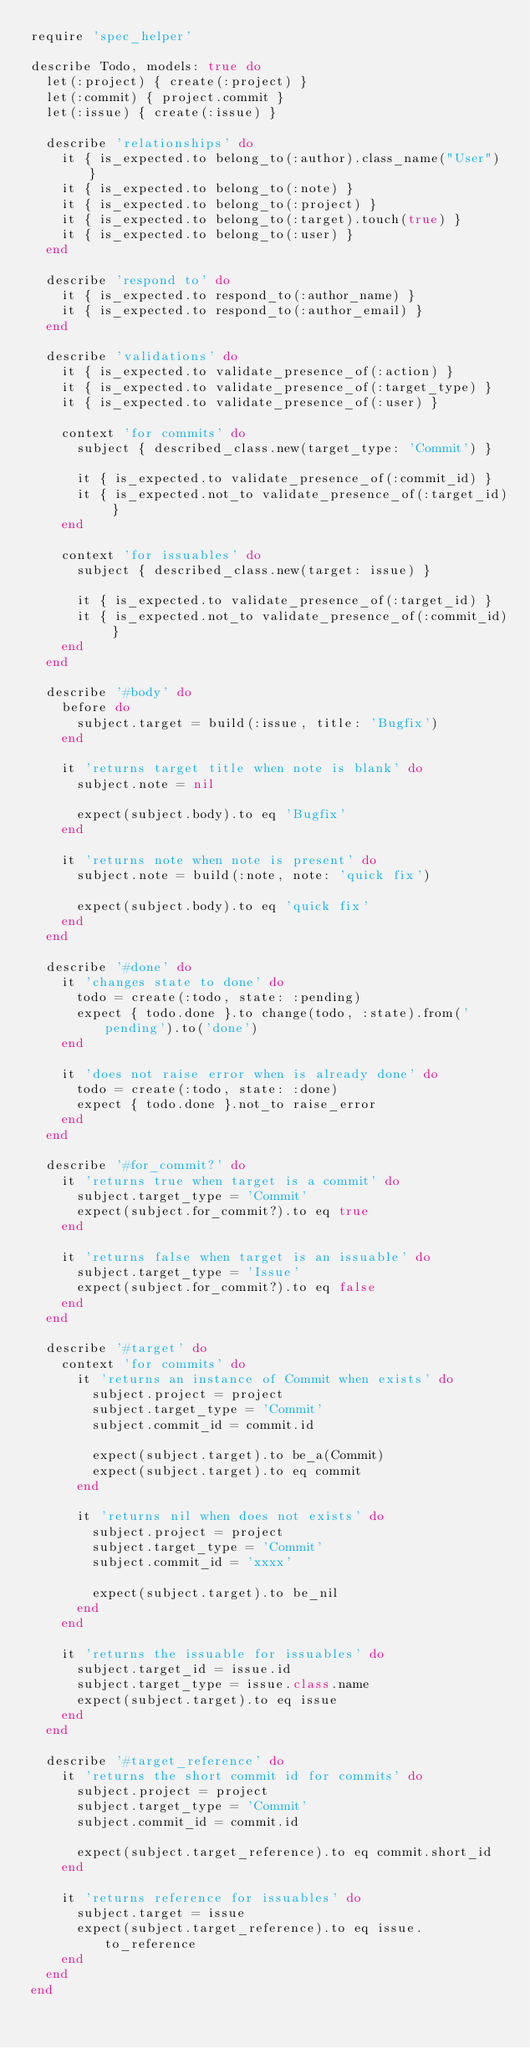Convert code to text. <code><loc_0><loc_0><loc_500><loc_500><_Ruby_>require 'spec_helper'

describe Todo, models: true do
  let(:project) { create(:project) }
  let(:commit) { project.commit }
  let(:issue) { create(:issue) }

  describe 'relationships' do
    it { is_expected.to belong_to(:author).class_name("User") }
    it { is_expected.to belong_to(:note) }
    it { is_expected.to belong_to(:project) }
    it { is_expected.to belong_to(:target).touch(true) }
    it { is_expected.to belong_to(:user) }
  end

  describe 'respond to' do
    it { is_expected.to respond_to(:author_name) }
    it { is_expected.to respond_to(:author_email) }
  end

  describe 'validations' do
    it { is_expected.to validate_presence_of(:action) }
    it { is_expected.to validate_presence_of(:target_type) }
    it { is_expected.to validate_presence_of(:user) }

    context 'for commits' do
      subject { described_class.new(target_type: 'Commit') }

      it { is_expected.to validate_presence_of(:commit_id) }
      it { is_expected.not_to validate_presence_of(:target_id) }
    end

    context 'for issuables' do
      subject { described_class.new(target: issue) }

      it { is_expected.to validate_presence_of(:target_id) }
      it { is_expected.not_to validate_presence_of(:commit_id) }
    end
  end

  describe '#body' do
    before do
      subject.target = build(:issue, title: 'Bugfix')
    end

    it 'returns target title when note is blank' do
      subject.note = nil

      expect(subject.body).to eq 'Bugfix'
    end

    it 'returns note when note is present' do
      subject.note = build(:note, note: 'quick fix')

      expect(subject.body).to eq 'quick fix'
    end
  end

  describe '#done' do
    it 'changes state to done' do
      todo = create(:todo, state: :pending)
      expect { todo.done }.to change(todo, :state).from('pending').to('done')
    end

    it 'does not raise error when is already done' do
      todo = create(:todo, state: :done)
      expect { todo.done }.not_to raise_error
    end
  end

  describe '#for_commit?' do
    it 'returns true when target is a commit' do
      subject.target_type = 'Commit'
      expect(subject.for_commit?).to eq true
    end

    it 'returns false when target is an issuable' do
      subject.target_type = 'Issue'
      expect(subject.for_commit?).to eq false
    end
  end

  describe '#target' do
    context 'for commits' do
      it 'returns an instance of Commit when exists' do
        subject.project = project
        subject.target_type = 'Commit'
        subject.commit_id = commit.id

        expect(subject.target).to be_a(Commit)
        expect(subject.target).to eq commit
      end

      it 'returns nil when does not exists' do
        subject.project = project
        subject.target_type = 'Commit'
        subject.commit_id = 'xxxx'

        expect(subject.target).to be_nil
      end
    end

    it 'returns the issuable for issuables' do
      subject.target_id = issue.id
      subject.target_type = issue.class.name
      expect(subject.target).to eq issue
    end
  end

  describe '#target_reference' do
    it 'returns the short commit id for commits' do
      subject.project = project
      subject.target_type = 'Commit'
      subject.commit_id = commit.id

      expect(subject.target_reference).to eq commit.short_id
    end

    it 'returns reference for issuables' do
      subject.target = issue
      expect(subject.target_reference).to eq issue.to_reference
    end
  end
end
</code> 